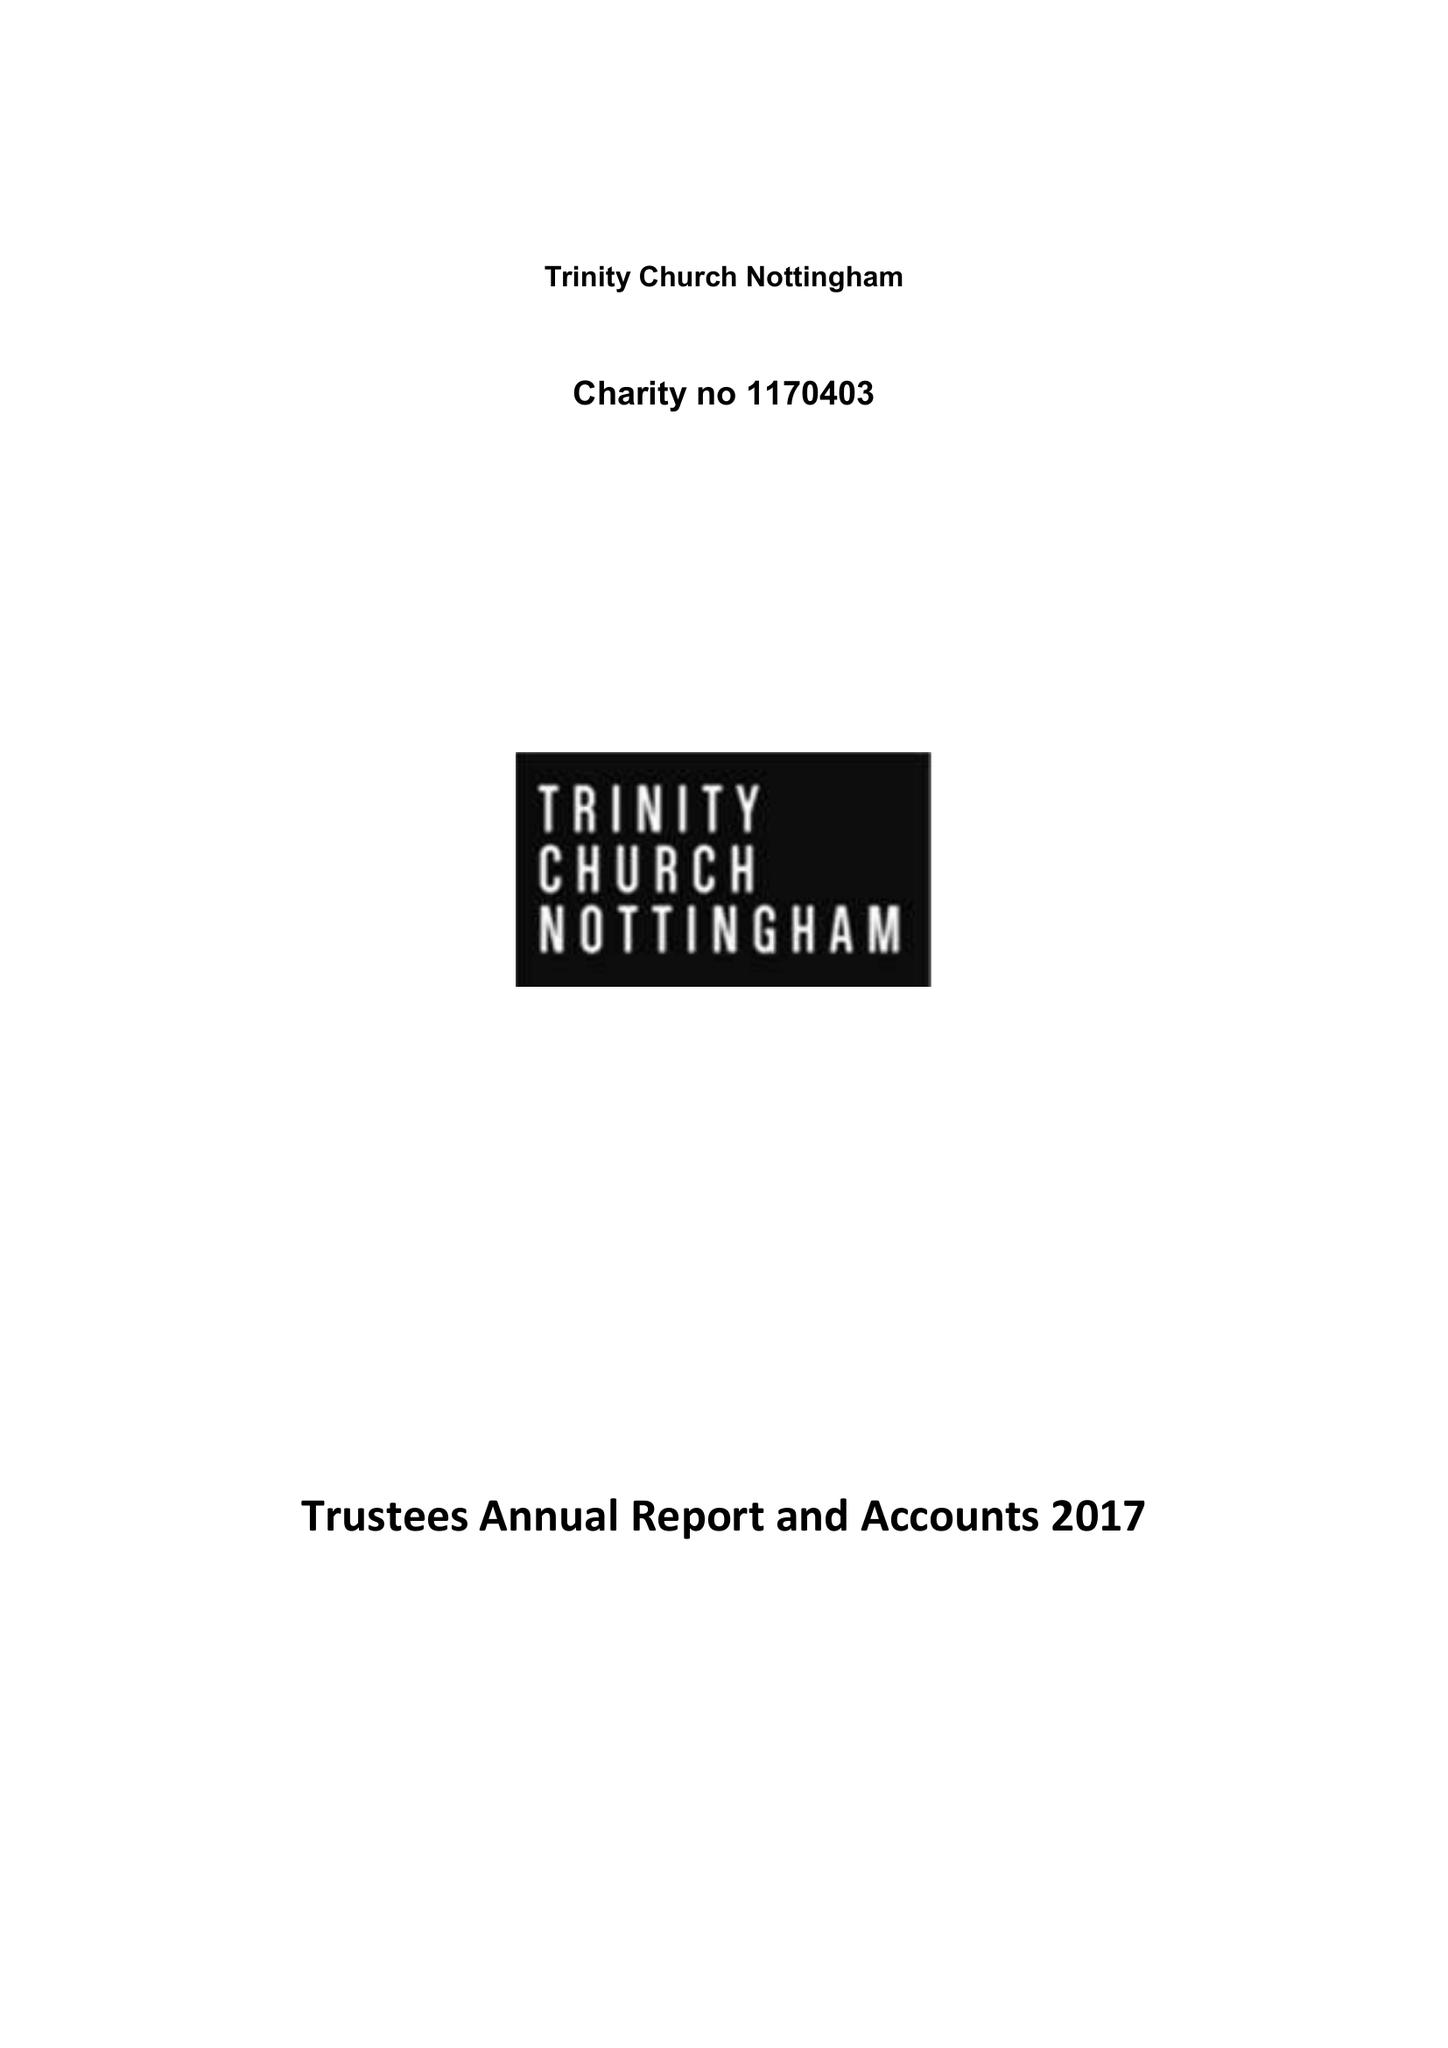What is the value for the spending_annually_in_british_pounds?
Answer the question using a single word or phrase. 103808.00 